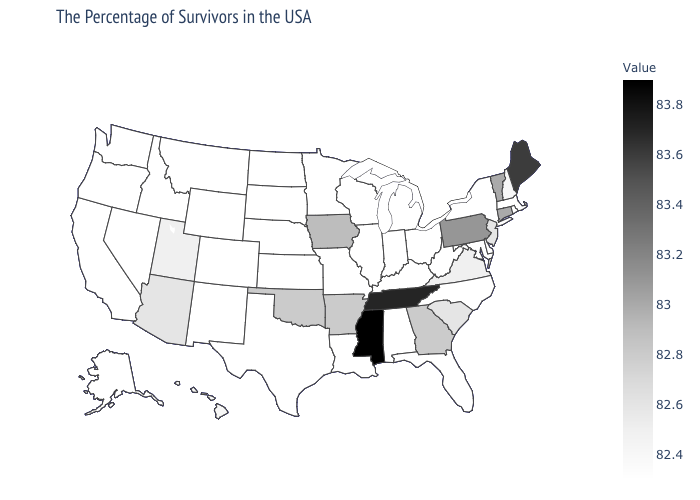Among the states that border Florida , which have the lowest value?
Concise answer only. Alabama. Does Arizona have the highest value in the West?
Give a very brief answer. Yes. Among the states that border New Mexico , which have the highest value?
Write a very short answer. Oklahoma. Does Mississippi have the highest value in the USA?
Give a very brief answer. Yes. Does Louisiana have the lowest value in the USA?
Short answer required. Yes. Does the map have missing data?
Quick response, please. No. 